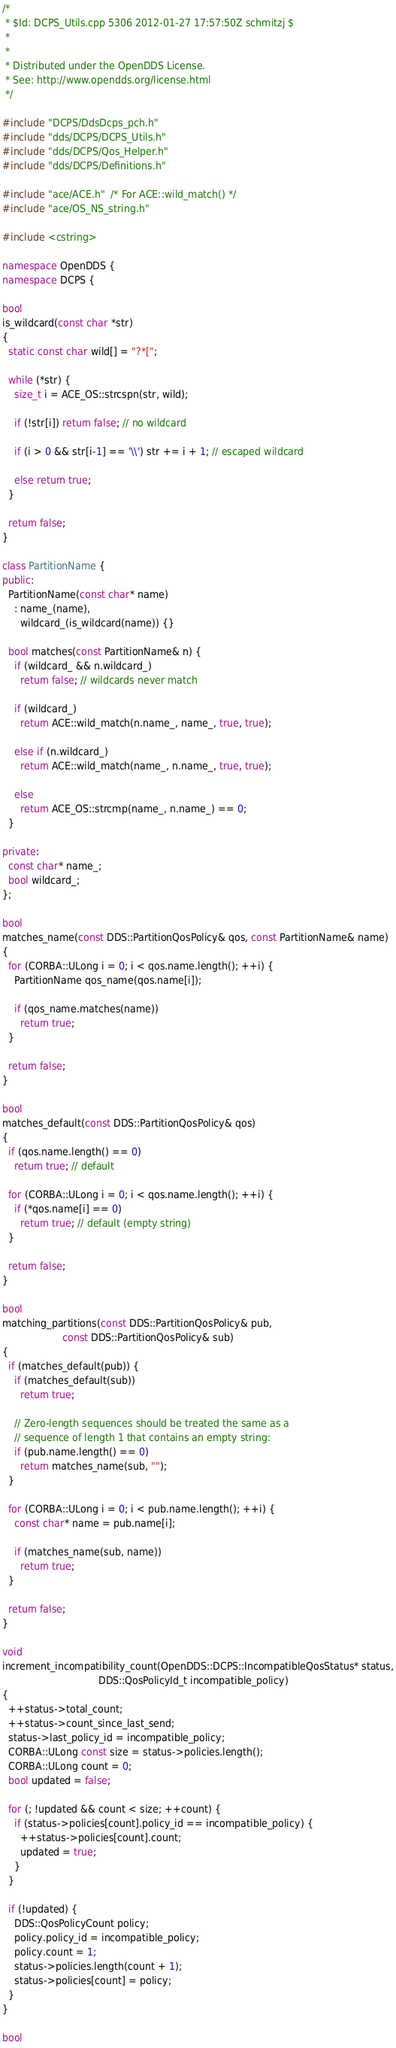Convert code to text. <code><loc_0><loc_0><loc_500><loc_500><_C++_>/*
 * $Id: DCPS_Utils.cpp 5306 2012-01-27 17:57:50Z schmitzj $
 *
 *
 * Distributed under the OpenDDS License.
 * See: http://www.opendds.org/license.html
 */

#include "DCPS/DdsDcps_pch.h"
#include "dds/DCPS/DCPS_Utils.h"
#include "dds/DCPS/Qos_Helper.h"
#include "dds/DCPS/Definitions.h"

#include "ace/ACE.h"  /* For ACE::wild_match() */
#include "ace/OS_NS_string.h"

#include <cstring>

namespace OpenDDS {
namespace DCPS {

bool
is_wildcard(const char *str)
{
  static const char wild[] = "?*[";

  while (*str) {
    size_t i = ACE_OS::strcspn(str, wild);

    if (!str[i]) return false; // no wildcard

    if (i > 0 && str[i-1] == '\\') str += i + 1; // escaped wildcard

    else return true;
  }

  return false;
}

class PartitionName {
public:
  PartitionName(const char* name)
    : name_(name),
      wildcard_(is_wildcard(name)) {}

  bool matches(const PartitionName& n) {
    if (wildcard_ && n.wildcard_)
      return false; // wildcards never match

    if (wildcard_)
      return ACE::wild_match(n.name_, name_, true, true);

    else if (n.wildcard_)
      return ACE::wild_match(name_, n.name_, true, true);

    else
      return ACE_OS::strcmp(name_, n.name_) == 0;
  }

private:
  const char* name_;
  bool wildcard_;
};

bool
matches_name(const DDS::PartitionQosPolicy& qos, const PartitionName& name)
{
  for (CORBA::ULong i = 0; i < qos.name.length(); ++i) {
    PartitionName qos_name(qos.name[i]);

    if (qos_name.matches(name))
      return true;
  }

  return false;
}

bool
matches_default(const DDS::PartitionQosPolicy& qos)
{
  if (qos.name.length() == 0)
    return true; // default

  for (CORBA::ULong i = 0; i < qos.name.length(); ++i) {
    if (*qos.name[i] == 0)
      return true; // default (empty string)
  }

  return false;
}

bool
matching_partitions(const DDS::PartitionQosPolicy& pub,
                    const DDS::PartitionQosPolicy& sub)
{
  if (matches_default(pub)) {
    if (matches_default(sub))
      return true;

    // Zero-length sequences should be treated the same as a
    // sequence of length 1 that contains an empty string:
    if (pub.name.length() == 0)
      return matches_name(sub, "");
  }

  for (CORBA::ULong i = 0; i < pub.name.length(); ++i) {
    const char* name = pub.name[i];

    if (matches_name(sub, name))
      return true;
  }

  return false;
}

void
increment_incompatibility_count(OpenDDS::DCPS::IncompatibleQosStatus* status,
                                DDS::QosPolicyId_t incompatible_policy)
{
  ++status->total_count;
  ++status->count_since_last_send;
  status->last_policy_id = incompatible_policy;
  CORBA::ULong const size = status->policies.length();
  CORBA::ULong count = 0;
  bool updated = false;

  for (; !updated && count < size; ++count) {
    if (status->policies[count].policy_id == incompatible_policy) {
      ++status->policies[count].count;
      updated = true;
    }
  }

  if (!updated) {
    DDS::QosPolicyCount policy;
    policy.policy_id = incompatible_policy;
    policy.count = 1;
    status->policies.length(count + 1);
    status->policies[count] = policy;
  }
}

bool</code> 